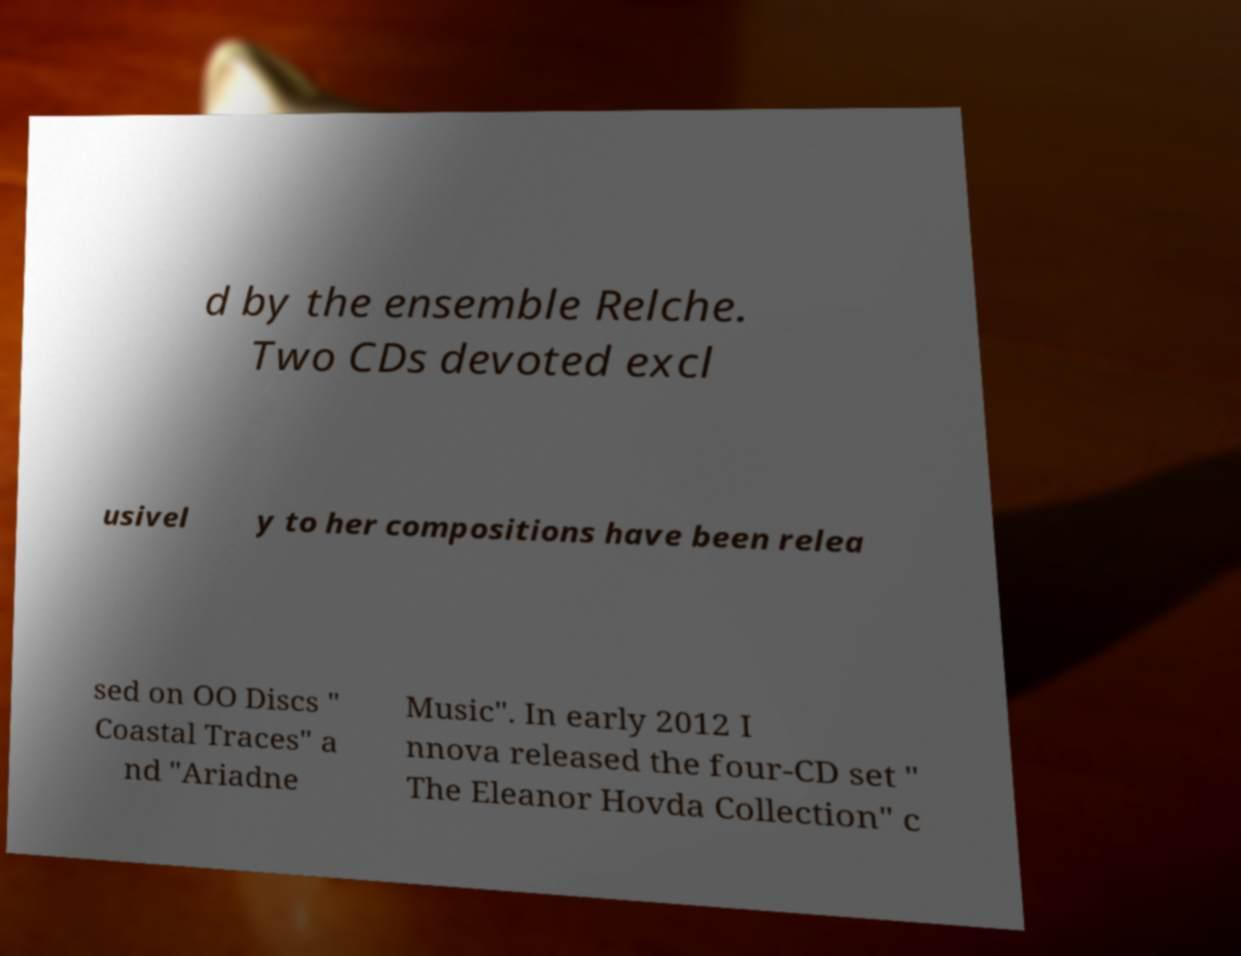For documentation purposes, I need the text within this image transcribed. Could you provide that? d by the ensemble Relche. Two CDs devoted excl usivel y to her compositions have been relea sed on OO Discs " Coastal Traces" a nd "Ariadne Music". In early 2012 I nnova released the four-CD set " The Eleanor Hovda Collection" c 